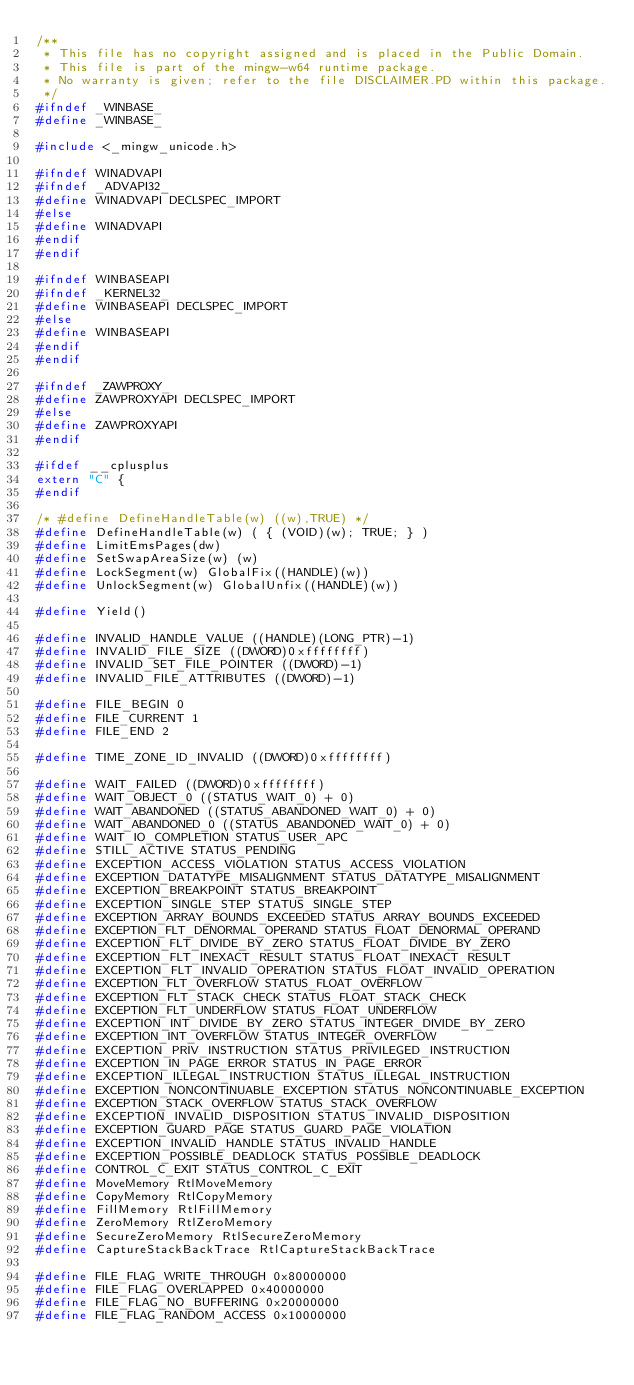Convert code to text. <code><loc_0><loc_0><loc_500><loc_500><_C_>/**
 * This file has no copyright assigned and is placed in the Public Domain.
 * This file is part of the mingw-w64 runtime package.
 * No warranty is given; refer to the file DISCLAIMER.PD within this package.
 */
#ifndef _WINBASE_
#define _WINBASE_

#include <_mingw_unicode.h>

#ifndef WINADVAPI
#ifndef _ADVAPI32_
#define WINADVAPI DECLSPEC_IMPORT
#else
#define WINADVAPI
#endif
#endif

#ifndef WINBASEAPI
#ifndef _KERNEL32_
#define WINBASEAPI DECLSPEC_IMPORT
#else
#define WINBASEAPI
#endif
#endif

#ifndef _ZAWPROXY_
#define ZAWPROXYAPI DECLSPEC_IMPORT
#else
#define ZAWPROXYAPI
#endif

#ifdef __cplusplus
extern "C" {
#endif

/* #define DefineHandleTable(w) ((w),TRUE) */
#define DefineHandleTable(w) ( { (VOID)(w); TRUE; } )
#define LimitEmsPages(dw)
#define SetSwapAreaSize(w) (w)
#define LockSegment(w) GlobalFix((HANDLE)(w))
#define UnlockSegment(w) GlobalUnfix((HANDLE)(w))

#define Yield()

#define INVALID_HANDLE_VALUE ((HANDLE)(LONG_PTR)-1)
#define INVALID_FILE_SIZE ((DWORD)0xffffffff)
#define INVALID_SET_FILE_POINTER ((DWORD)-1)
#define INVALID_FILE_ATTRIBUTES ((DWORD)-1)

#define FILE_BEGIN 0
#define FILE_CURRENT 1
#define FILE_END 2

#define TIME_ZONE_ID_INVALID ((DWORD)0xffffffff)

#define WAIT_FAILED ((DWORD)0xffffffff)
#define WAIT_OBJECT_0 ((STATUS_WAIT_0) + 0)
#define WAIT_ABANDONED ((STATUS_ABANDONED_WAIT_0) + 0)
#define WAIT_ABANDONED_0 ((STATUS_ABANDONED_WAIT_0) + 0)
#define WAIT_IO_COMPLETION STATUS_USER_APC
#define STILL_ACTIVE STATUS_PENDING
#define EXCEPTION_ACCESS_VIOLATION STATUS_ACCESS_VIOLATION
#define EXCEPTION_DATATYPE_MISALIGNMENT STATUS_DATATYPE_MISALIGNMENT
#define EXCEPTION_BREAKPOINT STATUS_BREAKPOINT
#define EXCEPTION_SINGLE_STEP STATUS_SINGLE_STEP
#define EXCEPTION_ARRAY_BOUNDS_EXCEEDED STATUS_ARRAY_BOUNDS_EXCEEDED
#define EXCEPTION_FLT_DENORMAL_OPERAND STATUS_FLOAT_DENORMAL_OPERAND
#define EXCEPTION_FLT_DIVIDE_BY_ZERO STATUS_FLOAT_DIVIDE_BY_ZERO
#define EXCEPTION_FLT_INEXACT_RESULT STATUS_FLOAT_INEXACT_RESULT
#define EXCEPTION_FLT_INVALID_OPERATION STATUS_FLOAT_INVALID_OPERATION
#define EXCEPTION_FLT_OVERFLOW STATUS_FLOAT_OVERFLOW
#define EXCEPTION_FLT_STACK_CHECK STATUS_FLOAT_STACK_CHECK
#define EXCEPTION_FLT_UNDERFLOW STATUS_FLOAT_UNDERFLOW
#define EXCEPTION_INT_DIVIDE_BY_ZERO STATUS_INTEGER_DIVIDE_BY_ZERO
#define EXCEPTION_INT_OVERFLOW STATUS_INTEGER_OVERFLOW
#define EXCEPTION_PRIV_INSTRUCTION STATUS_PRIVILEGED_INSTRUCTION
#define EXCEPTION_IN_PAGE_ERROR STATUS_IN_PAGE_ERROR
#define EXCEPTION_ILLEGAL_INSTRUCTION STATUS_ILLEGAL_INSTRUCTION
#define EXCEPTION_NONCONTINUABLE_EXCEPTION STATUS_NONCONTINUABLE_EXCEPTION
#define EXCEPTION_STACK_OVERFLOW STATUS_STACK_OVERFLOW
#define EXCEPTION_INVALID_DISPOSITION STATUS_INVALID_DISPOSITION
#define EXCEPTION_GUARD_PAGE STATUS_GUARD_PAGE_VIOLATION
#define EXCEPTION_INVALID_HANDLE STATUS_INVALID_HANDLE
#define EXCEPTION_POSSIBLE_DEADLOCK STATUS_POSSIBLE_DEADLOCK
#define CONTROL_C_EXIT STATUS_CONTROL_C_EXIT
#define MoveMemory RtlMoveMemory
#define CopyMemory RtlCopyMemory
#define FillMemory RtlFillMemory
#define ZeroMemory RtlZeroMemory
#define SecureZeroMemory RtlSecureZeroMemory
#define CaptureStackBackTrace RtlCaptureStackBackTrace

#define FILE_FLAG_WRITE_THROUGH 0x80000000
#define FILE_FLAG_OVERLAPPED 0x40000000
#define FILE_FLAG_NO_BUFFERING 0x20000000
#define FILE_FLAG_RANDOM_ACCESS 0x10000000</code> 